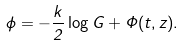Convert formula to latex. <formula><loc_0><loc_0><loc_500><loc_500>\phi = - \frac { k } { 2 } \log G + \Phi ( t , z ) .</formula> 